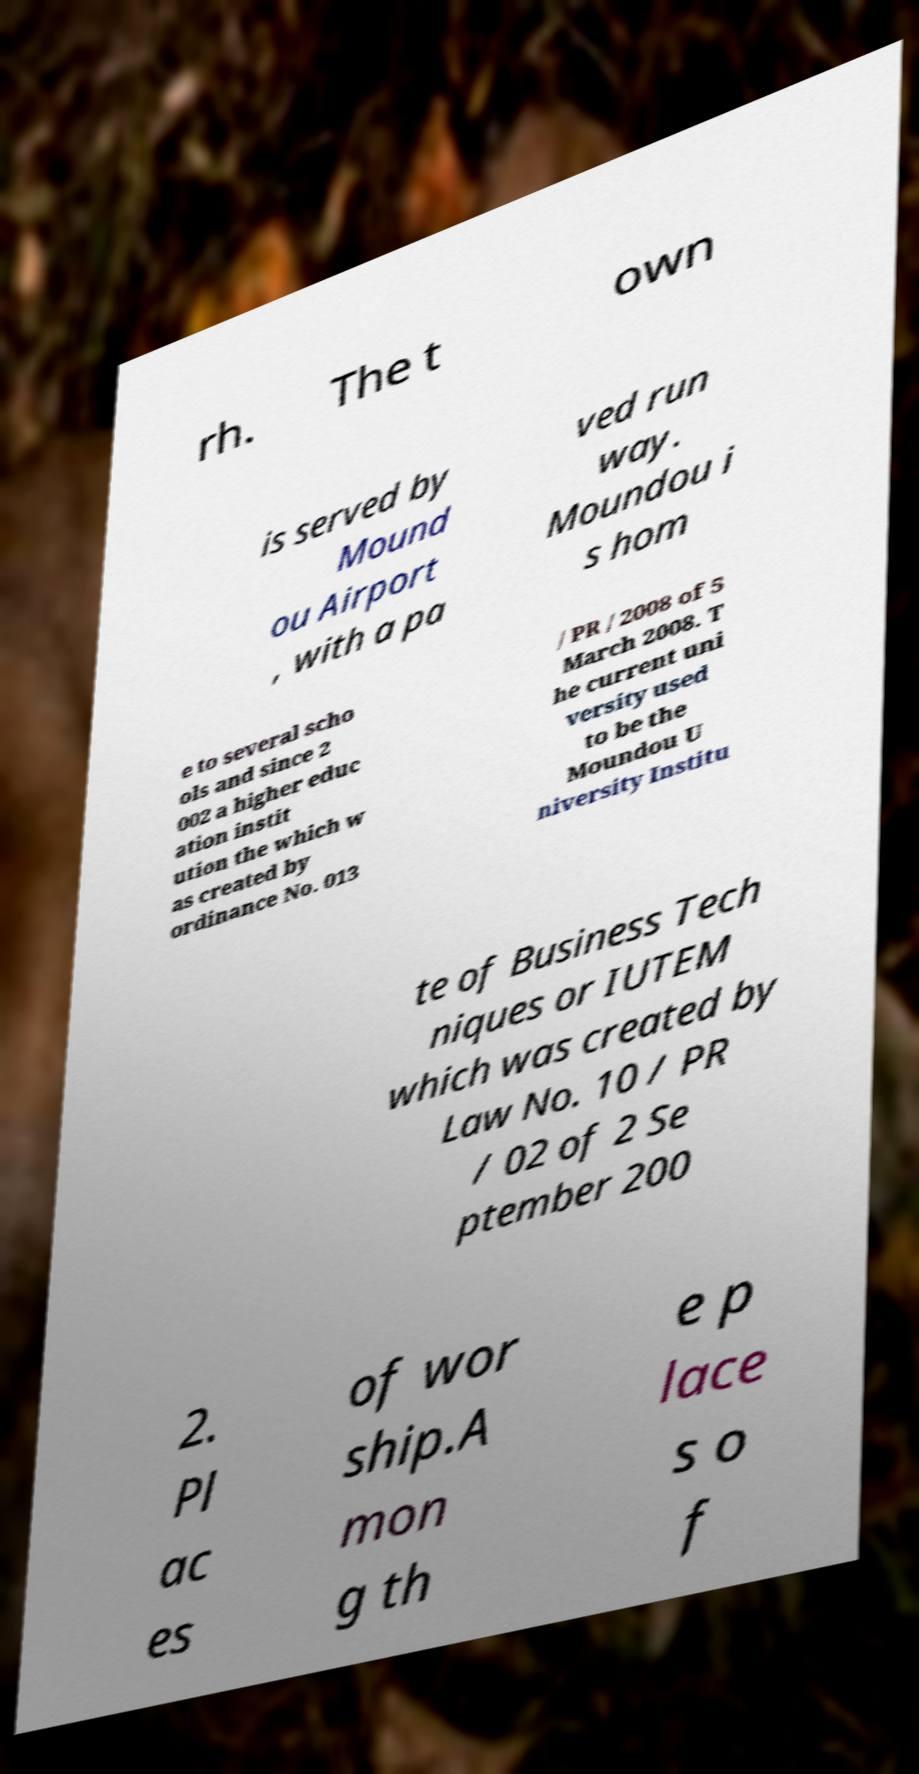Please identify and transcribe the text found in this image. rh. The t own is served by Mound ou Airport , with a pa ved run way. Moundou i s hom e to several scho ols and since 2 002 a higher educ ation instit ution the which w as created by ordinance No. 013 / PR / 2008 of 5 March 2008. T he current uni versity used to be the Moundou U niversity Institu te of Business Tech niques or IUTEM which was created by Law No. 10 / PR / 02 of 2 Se ptember 200 2. Pl ac es of wor ship.A mon g th e p lace s o f 